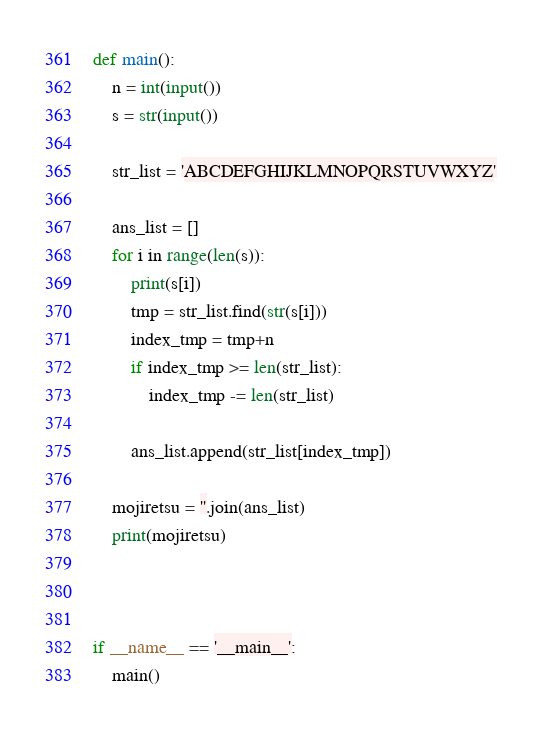Convert code to text. <code><loc_0><loc_0><loc_500><loc_500><_Python_>def main():
    n = int(input())
    s = str(input())

    str_list = 'ABCDEFGHIJKLMNOPQRSTUVWXYZ'

    ans_list = []
    for i in range(len(s)):
        print(s[i])
        tmp = str_list.find(str(s[i]))
        index_tmp = tmp+n
        if index_tmp >= len(str_list):
            index_tmp -= len(str_list)

        ans_list.append(str_list[index_tmp])

    mojiretsu = ''.join(ans_list)
    print(mojiretsu)



if __name__ == '__main__':
    main()

</code> 